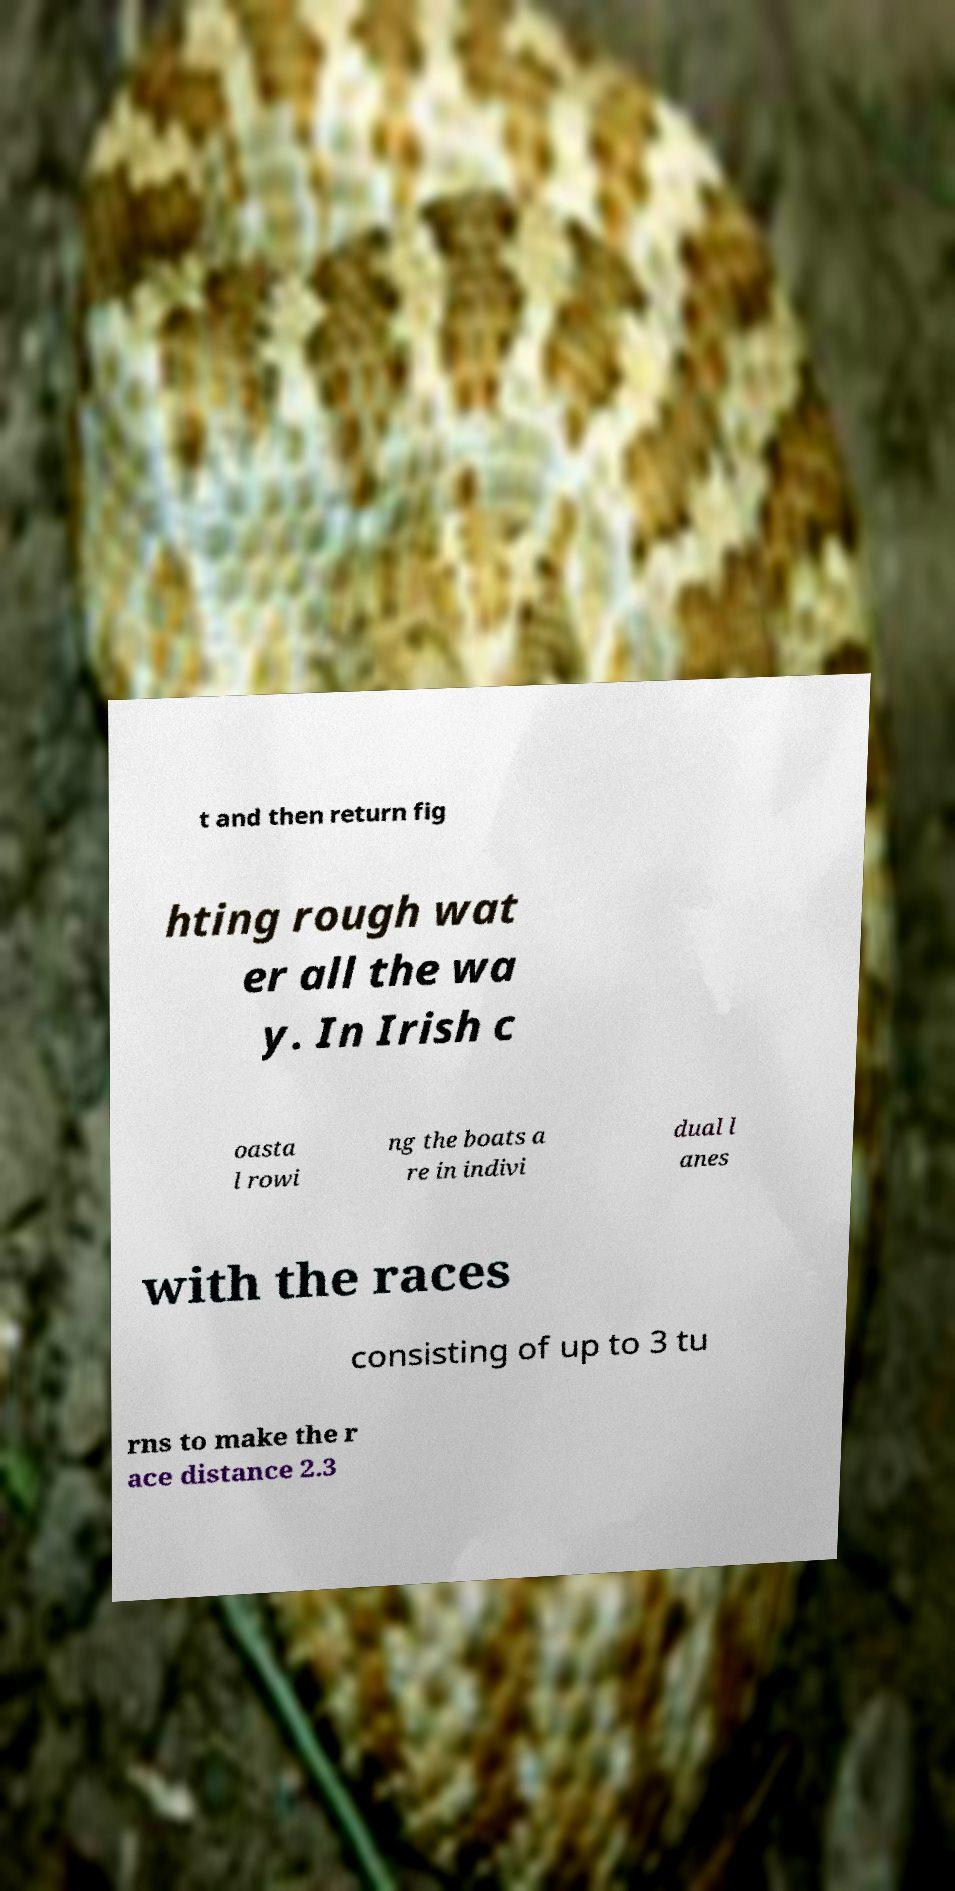I need the written content from this picture converted into text. Can you do that? t and then return fig hting rough wat er all the wa y. In Irish c oasta l rowi ng the boats a re in indivi dual l anes with the races consisting of up to 3 tu rns to make the r ace distance 2.3 